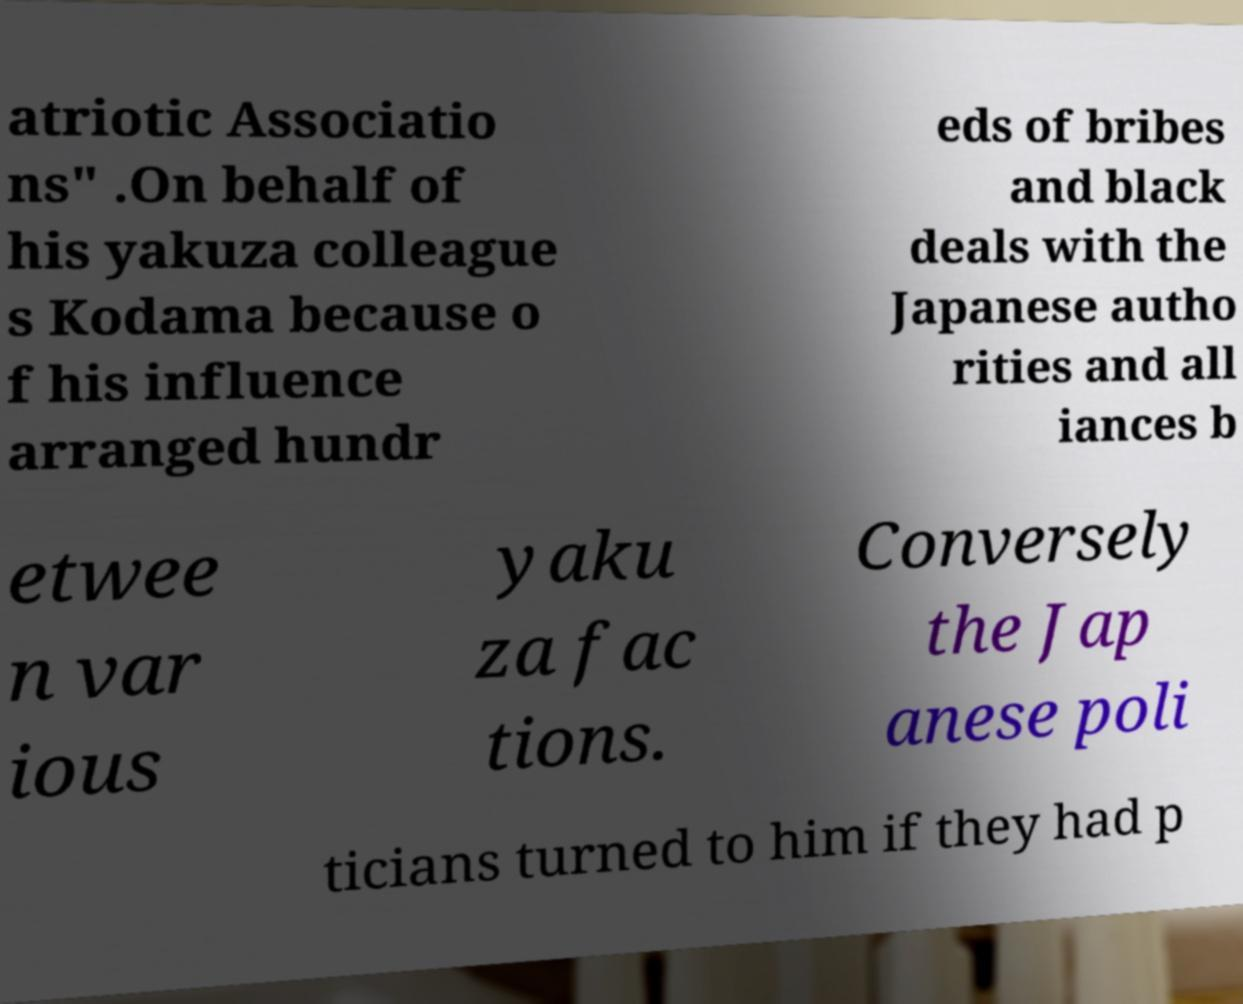Could you assist in decoding the text presented in this image and type it out clearly? atriotic Associatio ns" .On behalf of his yakuza colleague s Kodama because o f his influence arranged hundr eds of bribes and black deals with the Japanese autho rities and all iances b etwee n var ious yaku za fac tions. Conversely the Jap anese poli ticians turned to him if they had p 